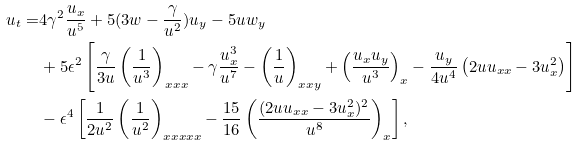<formula> <loc_0><loc_0><loc_500><loc_500>u _ { t } = & 4 \gamma ^ { 2 } \frac { u _ { x } } { u ^ { 5 } } + 5 ( 3 w - \frac { \gamma } { u ^ { 2 } } ) u _ { y } - 5 u w _ { y } \\ & + 5 \epsilon ^ { 2 } \left [ \frac { \gamma } { 3 u } \left ( \frac { 1 } { u ^ { 3 } } \right ) _ { x x x } - \gamma \frac { u _ { x } ^ { 3 } } { u ^ { 7 } } - \left ( \frac { 1 } { u } \right ) _ { x x y } + \left ( \frac { u _ { x } u _ { y } } { u ^ { 3 } } \right ) _ { x } - \frac { u _ { y } } { 4 u ^ { 4 } } \left ( 2 u u _ { x x } - 3 u _ { x } ^ { 2 } \right ) \right ] \\ & - \epsilon ^ { 4 } \left [ \frac { 1 } { 2 u ^ { 2 } } \left ( \frac { 1 } { u ^ { 2 } } \right ) _ { x x x x x } - \frac { 1 5 } { 1 6 } \left ( \frac { ( 2 u u _ { x x } - 3 u _ { x } ^ { 2 } ) ^ { 2 } } { u ^ { 8 } } \right ) _ { x } \right ] ,</formula> 